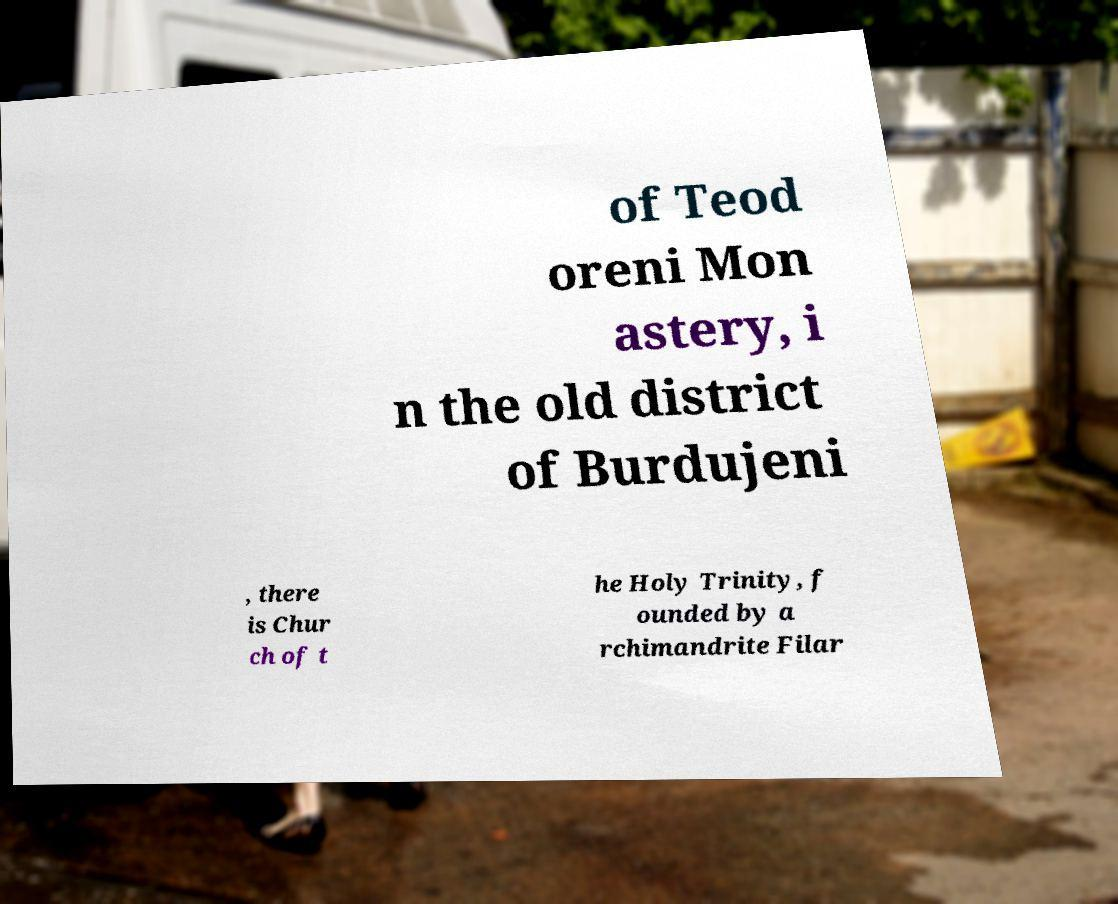Can you read and provide the text displayed in the image?This photo seems to have some interesting text. Can you extract and type it out for me? of Teod oreni Mon astery, i n the old district of Burdujeni , there is Chur ch of t he Holy Trinity, f ounded by a rchimandrite Filar 